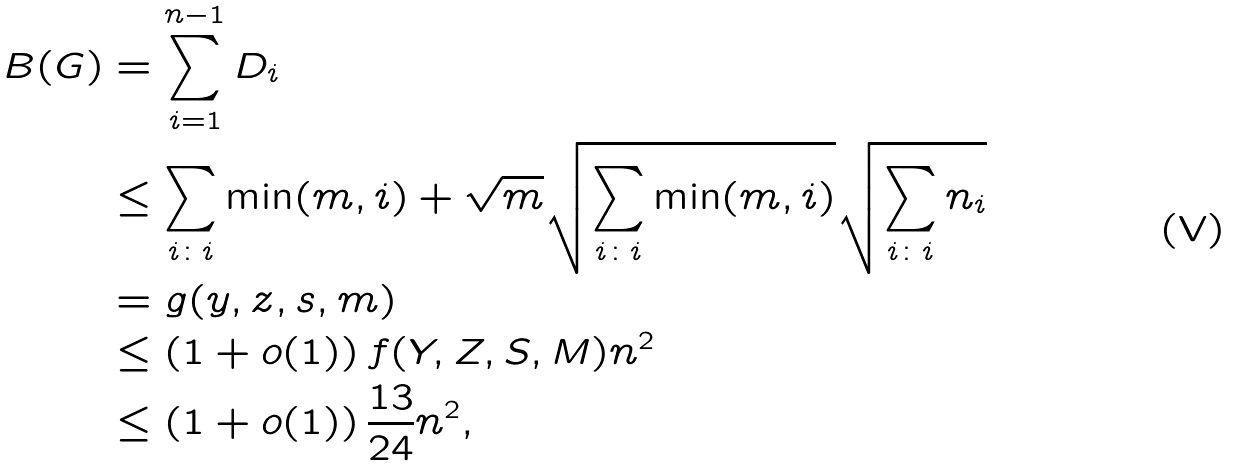<formula> <loc_0><loc_0><loc_500><loc_500>B ( G ) & = \sum _ { i = 1 } ^ { n - 1 } D _ { i } \\ & \leq \sum _ { i \colon i } \min ( m , i ) + \sqrt { m } \sqrt { \sum _ { i \colon i } \min ( m , i ) } \sqrt { \sum _ { i \colon i } n _ { i } } \\ & = g ( y , z , s , m ) \\ & \leq \left ( 1 + o ( 1 ) \right ) f ( Y , Z , S , M ) n ^ { 2 } \\ & \leq \left ( 1 + o ( 1 ) \right ) \frac { 1 3 } { 2 4 } n ^ { 2 } ,</formula> 